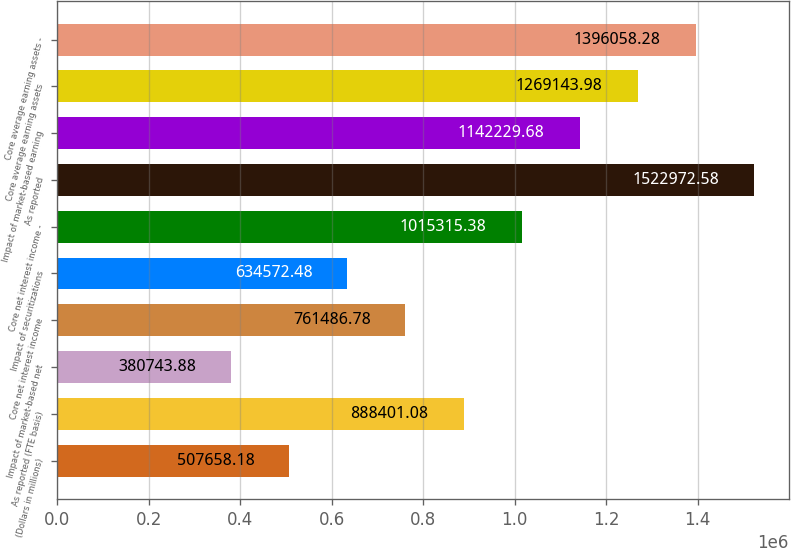Convert chart to OTSL. <chart><loc_0><loc_0><loc_500><loc_500><bar_chart><fcel>(Dollars in millions)<fcel>As reported (FTE basis)<fcel>Impact of market-based net<fcel>Core net interest income<fcel>Impact of securitizations<fcel>Core net interest income -<fcel>As reported<fcel>Impact of market-based earning<fcel>Core average earning assets<fcel>Core average earning assets -<nl><fcel>507658<fcel>888401<fcel>380744<fcel>761487<fcel>634572<fcel>1.01532e+06<fcel>1.52297e+06<fcel>1.14223e+06<fcel>1.26914e+06<fcel>1.39606e+06<nl></chart> 